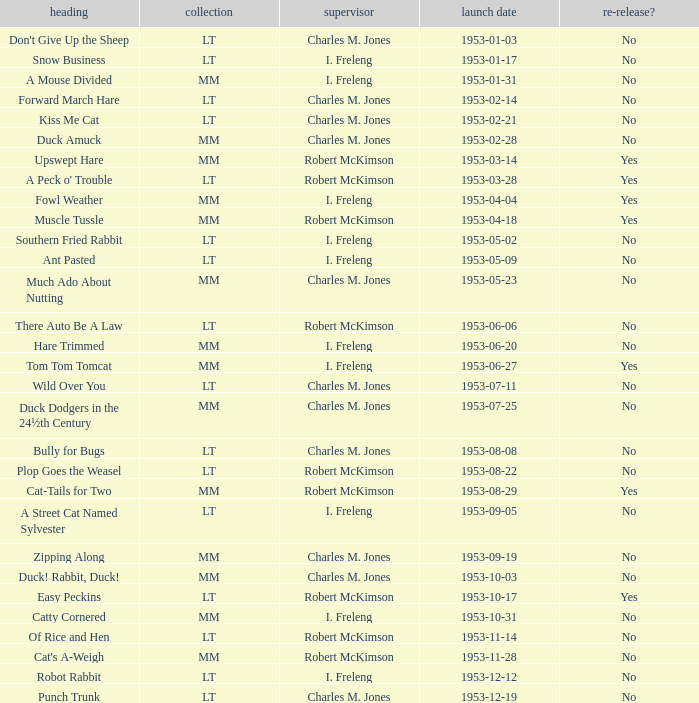What's the series of Kiss Me Cat? LT. 